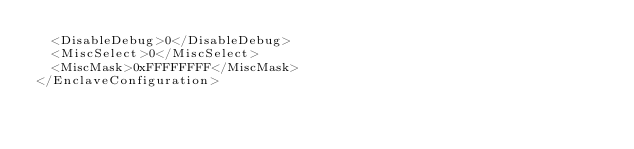<code> <loc_0><loc_0><loc_500><loc_500><_XML_>  <DisableDebug>0</DisableDebug>
  <MiscSelect>0</MiscSelect>
  <MiscMask>0xFFFFFFFF</MiscMask>
</EnclaveConfiguration>
</code> 